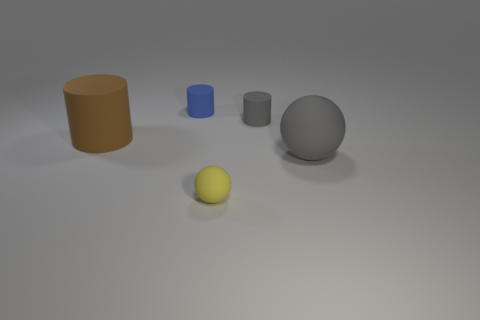Is the large brown cylinder that is on the left side of the large gray rubber sphere made of the same material as the gray cylinder?
Make the answer very short. Yes. Is there a brown rubber cylinder that has the same size as the gray matte sphere?
Your answer should be compact. Yes. Do the tiny gray object and the tiny object that is in front of the brown cylinder have the same shape?
Your answer should be compact. No. There is a large rubber thing that is right of the tiny rubber object in front of the large brown rubber object; are there any tiny blue rubber objects that are in front of it?
Offer a very short reply. No. What is the size of the brown cylinder?
Ensure brevity in your answer.  Large. How many other objects are there of the same color as the small ball?
Ensure brevity in your answer.  0. Do the big matte object to the right of the blue matte cylinder and the brown object have the same shape?
Your response must be concise. No. There is another small rubber object that is the same shape as the small blue object; what is its color?
Keep it short and to the point. Gray. There is a gray object that is the same shape as the blue matte object; what size is it?
Ensure brevity in your answer.  Small. There is a object that is to the right of the small yellow thing and to the left of the large gray matte ball; what material is it?
Your answer should be compact. Rubber. 